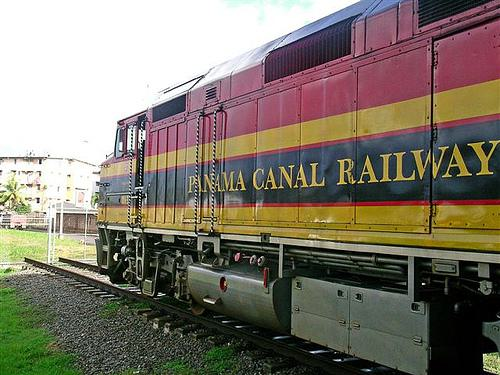What can you infer about the train's cargo based on its design? The train in the image appears to be a locomotive without attached freight or passenger cars, which makes it challenging to infer its specific cargo. However, the design of this particular engine suggests it's built for power and durability, often used for hauling significant weight, which could range from shipping containers to raw materials or passengers on a separate car. 